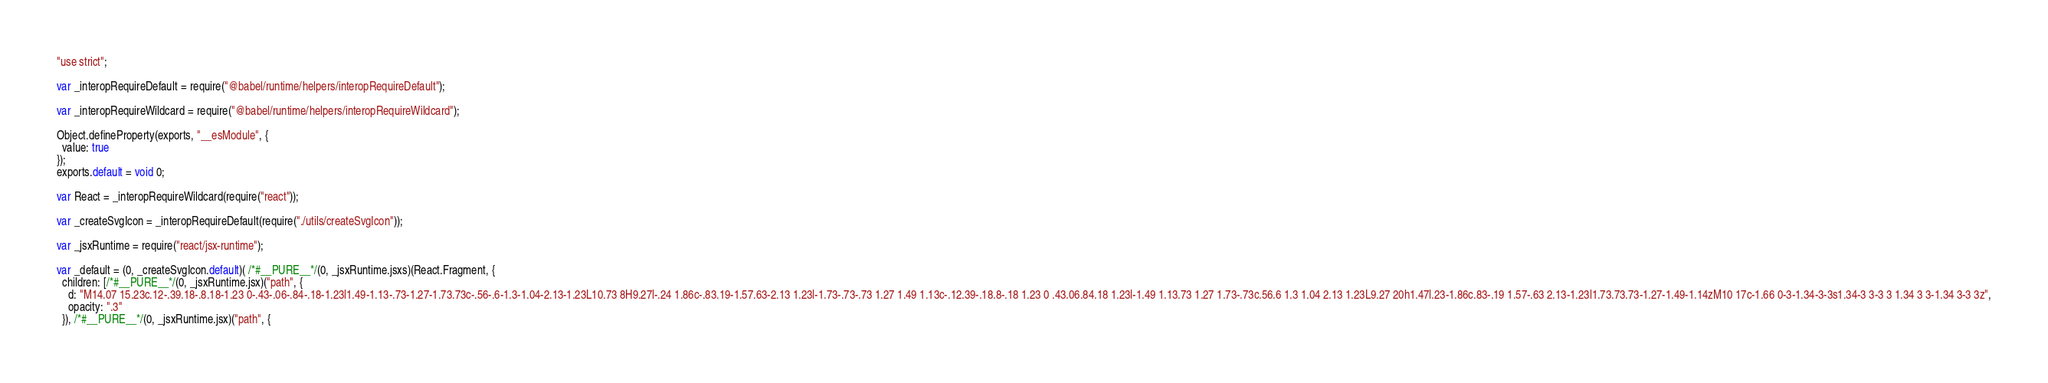<code> <loc_0><loc_0><loc_500><loc_500><_JavaScript_>"use strict";

var _interopRequireDefault = require("@babel/runtime/helpers/interopRequireDefault");

var _interopRequireWildcard = require("@babel/runtime/helpers/interopRequireWildcard");

Object.defineProperty(exports, "__esModule", {
  value: true
});
exports.default = void 0;

var React = _interopRequireWildcard(require("react"));

var _createSvgIcon = _interopRequireDefault(require("./utils/createSvgIcon"));

var _jsxRuntime = require("react/jsx-runtime");

var _default = (0, _createSvgIcon.default)( /*#__PURE__*/(0, _jsxRuntime.jsxs)(React.Fragment, {
  children: [/*#__PURE__*/(0, _jsxRuntime.jsx)("path", {
    d: "M14.07 15.23c.12-.39.18-.8.18-1.23 0-.43-.06-.84-.18-1.23l1.49-1.13-.73-1.27-1.73.73c-.56-.6-1.3-1.04-2.13-1.23L10.73 8H9.27l-.24 1.86c-.83.19-1.57.63-2.13 1.23l-1.73-.73-.73 1.27 1.49 1.13c-.12.39-.18.8-.18 1.23 0 .43.06.84.18 1.23l-1.49 1.13.73 1.27 1.73-.73c.56.6 1.3 1.04 2.13 1.23L9.27 20h1.47l.23-1.86c.83-.19 1.57-.63 2.13-1.23l1.73.73.73-1.27-1.49-1.14zM10 17c-1.66 0-3-1.34-3-3s1.34-3 3-3 3 1.34 3 3-1.34 3-3 3z",
    opacity: ".3"
  }), /*#__PURE__*/(0, _jsxRuntime.jsx)("path", {</code> 